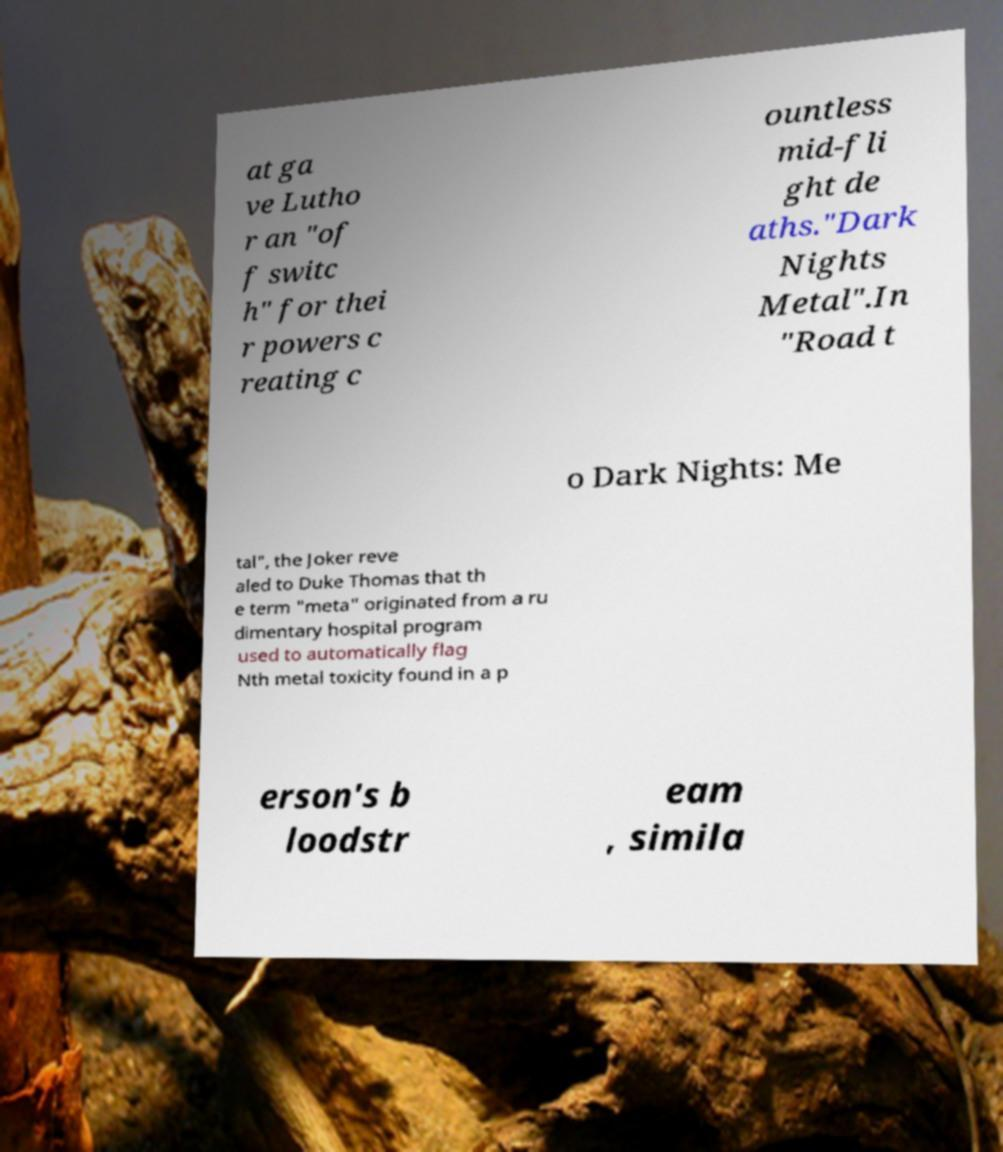Can you accurately transcribe the text from the provided image for me? at ga ve Lutho r an "of f switc h" for thei r powers c reating c ountless mid-fli ght de aths."Dark Nights Metal".In "Road t o Dark Nights: Me tal", the Joker reve aled to Duke Thomas that th e term "meta" originated from a ru dimentary hospital program used to automatically flag Nth metal toxicity found in a p erson's b loodstr eam , simila 